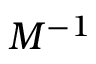Convert formula to latex. <formula><loc_0><loc_0><loc_500><loc_500>M ^ { - 1 }</formula> 